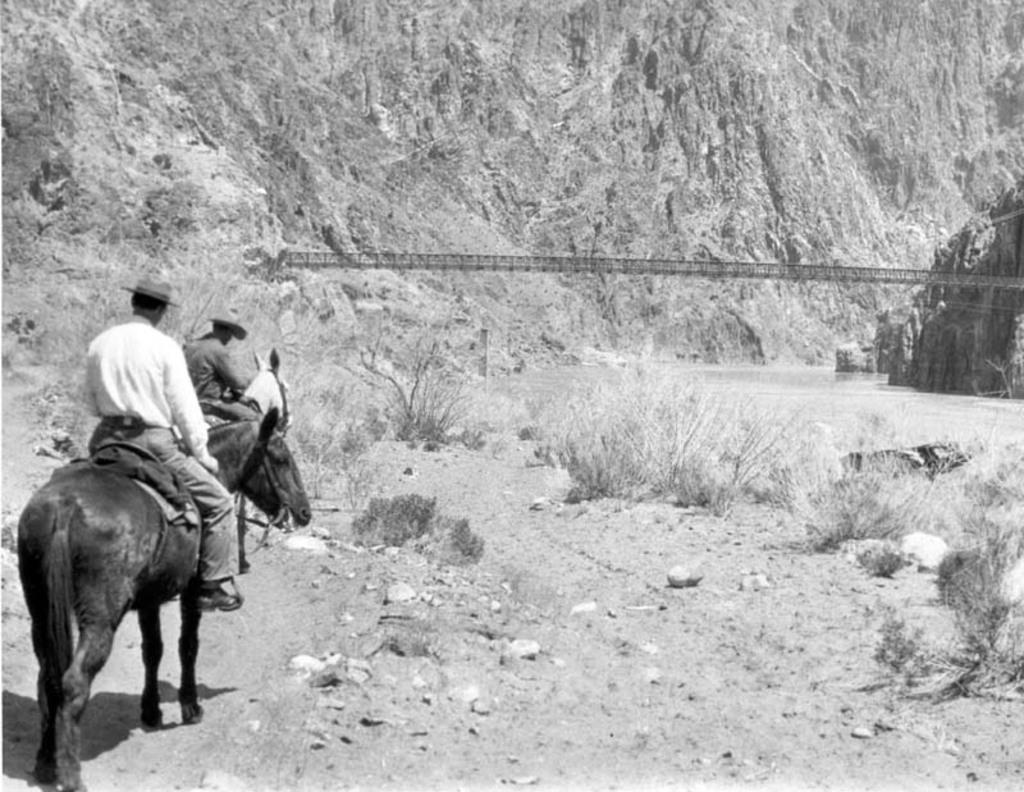What type of landscape is depicted in the image? There is a hill in the image. What type of vegetation is present in the image? There is grass in the image. How many people are in the image? There are two people in the image. What are the two people doing in the image? The two people are sitting on horses. What type of fowl can be seen flying over the wilderness in the image? There is no fowl or wilderness present in the image; it features a hill, grass, and two people sitting on horses. How many people are jumping in the image? There are no people jumping in the image; the two people are sitting on horses. 